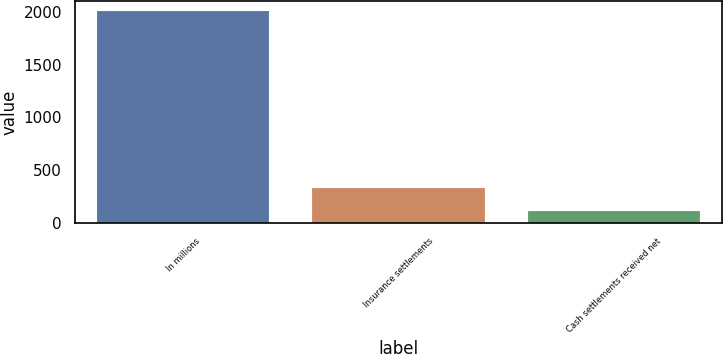Convert chart to OTSL. <chart><loc_0><loc_0><loc_500><loc_500><bar_chart><fcel>In millions<fcel>Insurance settlements<fcel>Cash settlements received net<nl><fcel>2005<fcel>334<fcel>114<nl></chart> 